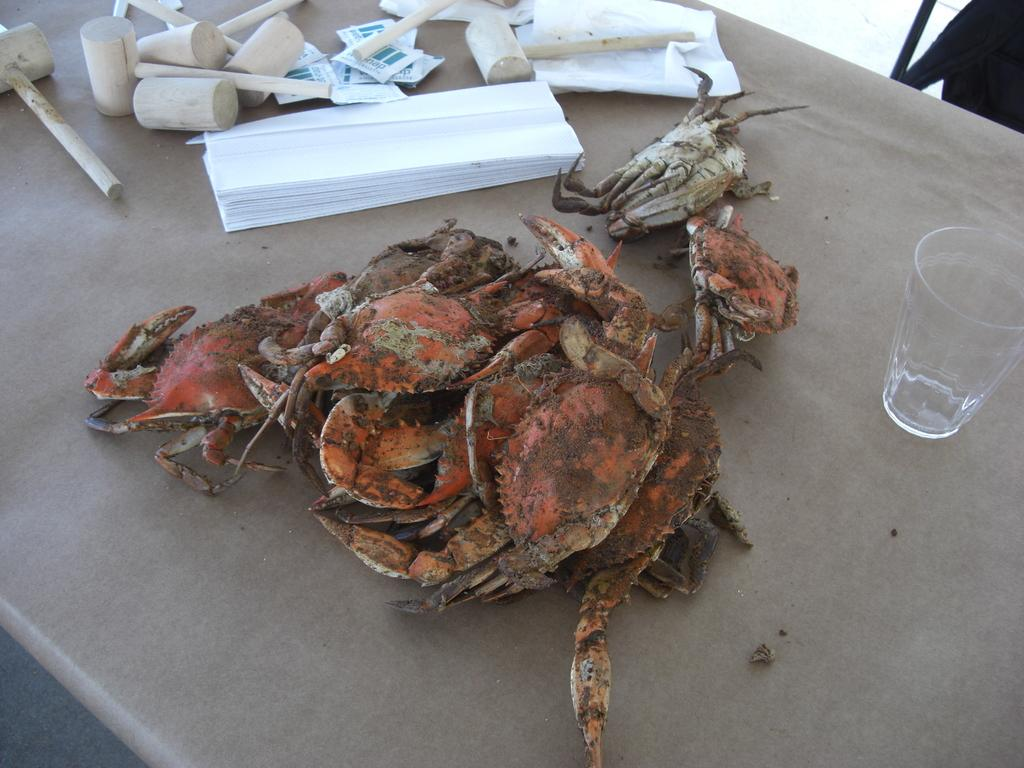What type of furniture is in the image? There is a table in the image. What is on top of the table? Crabs, a glass, papers, and wooden objects are present on the table. What color is the object in the top right of the image? There is a black color object in the top right of the image. What type of committee meeting is taking place in the image? There is no committee meeting present in the image; it features a table with various objects on it. Can you see a rabbit or a frog in the image? There is no rabbit or frog present in the image. 